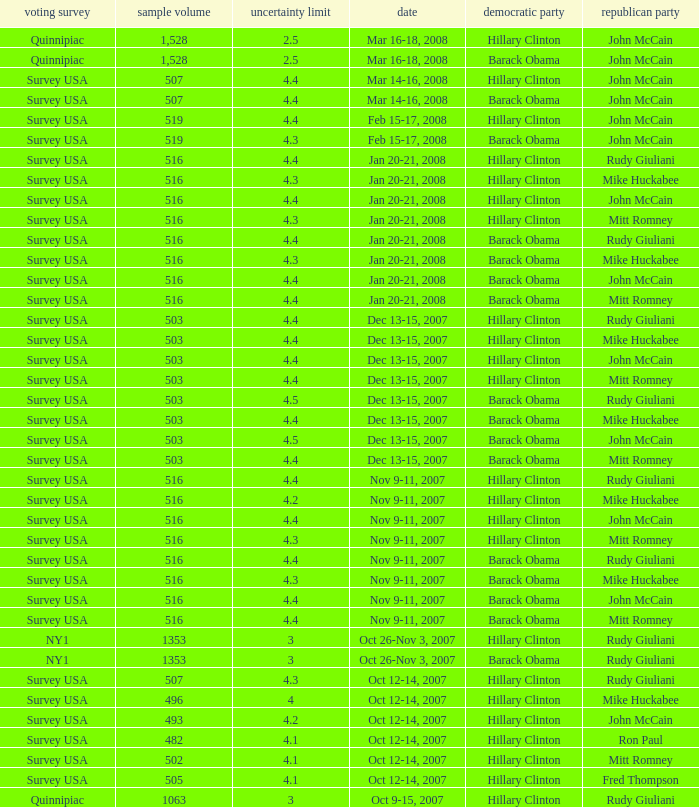What was the date of the poll with a sample size of 496 where Republican Mike Huckabee was chosen? Oct 12-14, 2007. 